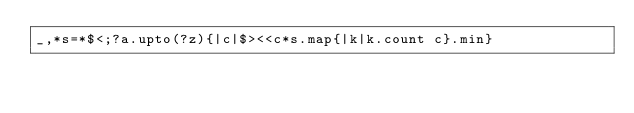<code> <loc_0><loc_0><loc_500><loc_500><_Ruby_>_,*s=*$<;?a.upto(?z){|c|$><<c*s.map{|k|k.count c}.min}</code> 